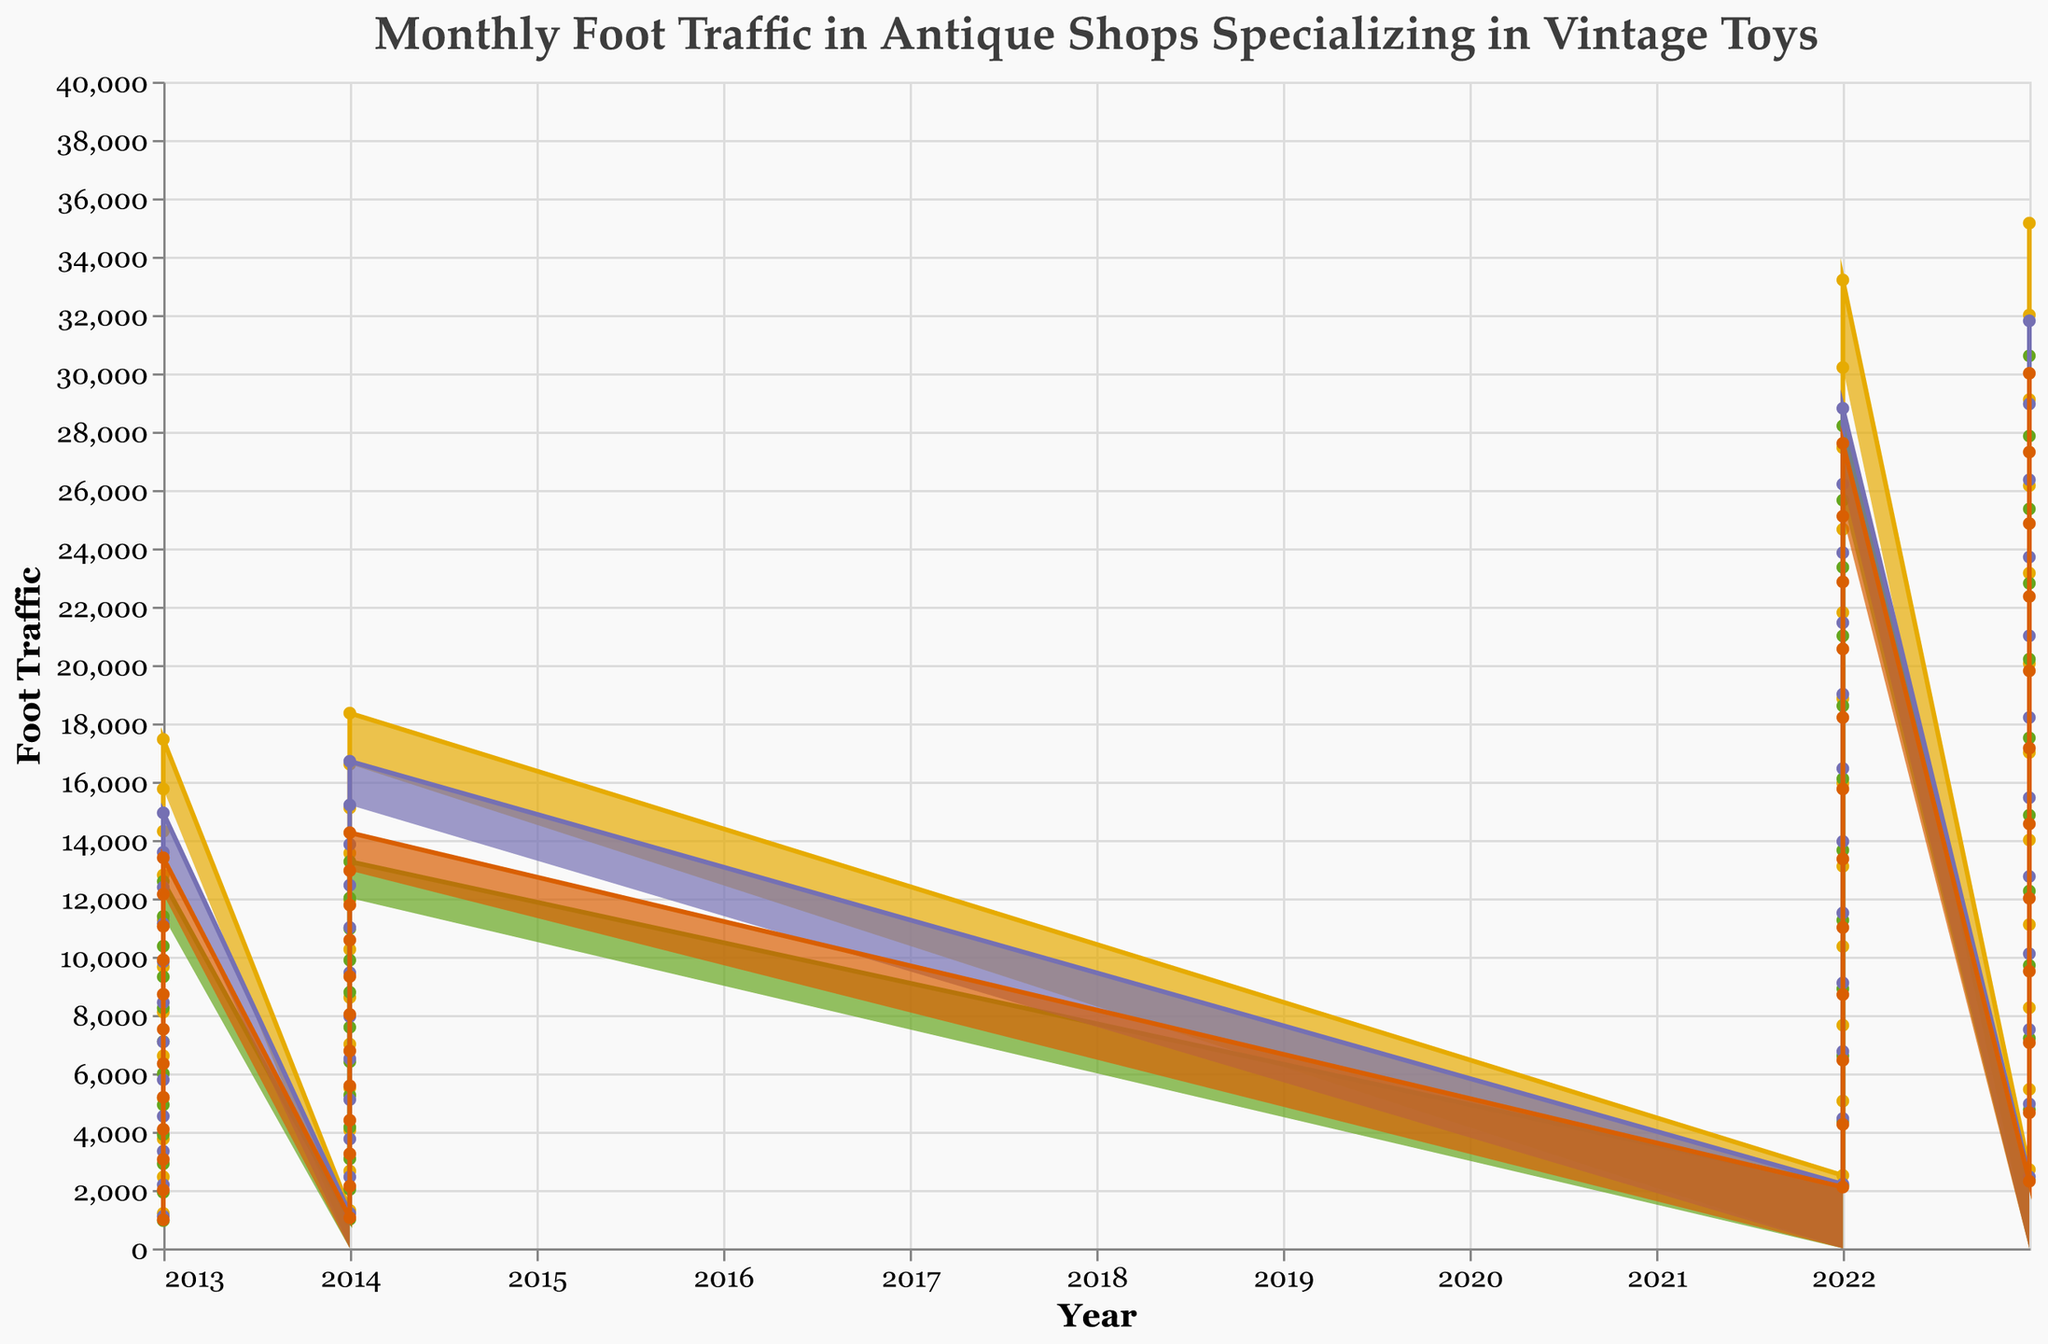What's the overall trend for ToysHeaven's foot traffic from 2013 to 2023? By observing the area chart, the foot traffic for ToysHeaven increases over time, starting at approximately 1200 in 2013 and rising to around 3150 in December 2023.
Answer: Increasing trend During which year did OldieTreasures have the highest foot traffic? The highest peak for OldieTreasures can be observed in December 2023, where the foot traffic reaches 2700.
Answer: 2023 Which shop has the most fluctuating foot traffic between 2013 and 2023? By comparing the lines for each shop, ToysHeaven shows significant fluctuations, with a large increase between 2021 and 2023. In contrast, other shops show more gradual changes.
Answer: ToysHeaven What can be said about the foot traffic for RetroRevival in December each year? By observing the December data points from each year, RetroRevival's foot traffic starts at 1200 in 2013, modestly increases over the years, and peaks at 2750 in 2023.
Answer: Increasing How did the foot traffic for VintageVault change from January 2022 compared to January 2023? In January 2022, foot traffic for VintageVault was 2200, and by January 2023, it increased to 2450, indicating a growth.
Answer: Increased by 250 Which shop has the highest foot traffic in December 2023? From the figure, it is clear that ToysHeaven has the highest foot traffic in December 2023, reaching 3150.
Answer: ToysHeaven Calculate the average foot traffic for ToysHeaven in 2023. Adding monthly foot traffic for ToysHeaven in 2023: 2700+2750+2800+2850+2900+3000+3050+3100+3000+2950+2900+3150 equals 36400. Dividing by 12 gives 3033.33.
Answer: 3033.33 By how much did the foot traffic for RetroRevival increase from January 2013 to January 2023? RetroRevival's foot traffic was 950 in January 2013 and 2350 in January 2023. The increase is 2350 - 950 = 1400.
Answer: 1400 Which shop had the lowest foot traffic in January 2022? Observing the January 2022 data points, OldieTreasures had the lowest foot traffic with 2100.
Answer: OldieTreasures 